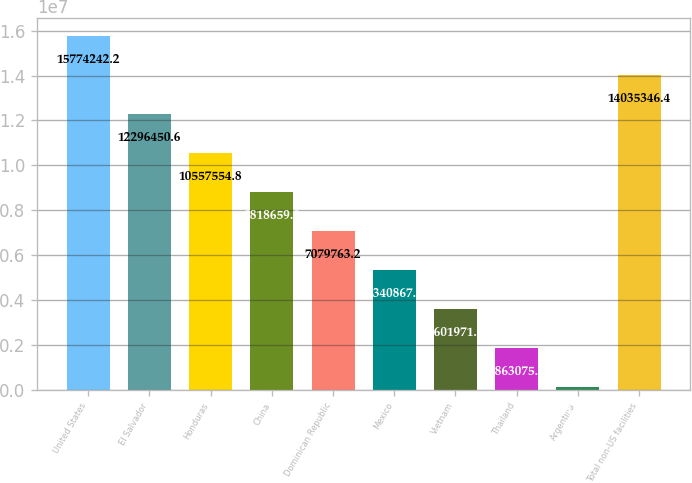<chart> <loc_0><loc_0><loc_500><loc_500><bar_chart><fcel>United States<fcel>El Salvador<fcel>Honduras<fcel>China<fcel>Dominican Republic<fcel>Mexico<fcel>Vietnam<fcel>Thailand<fcel>Argentina<fcel>Total non-US facilities<nl><fcel>1.57742e+07<fcel>1.22965e+07<fcel>1.05576e+07<fcel>8.81866e+06<fcel>7.07976e+06<fcel>5.34087e+06<fcel>3.60197e+06<fcel>1.86308e+06<fcel>124180<fcel>1.40353e+07<nl></chart> 